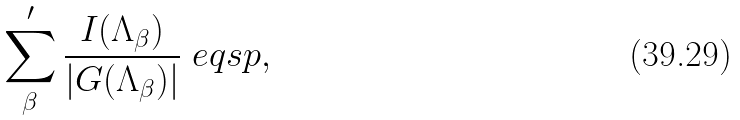<formula> <loc_0><loc_0><loc_500><loc_500>\sum _ { \beta } ^ { \prime } \frac { I ( \Lambda _ { \beta } ) } { | G ( \Lambda _ { \beta } ) | } \ e q s p ,</formula> 